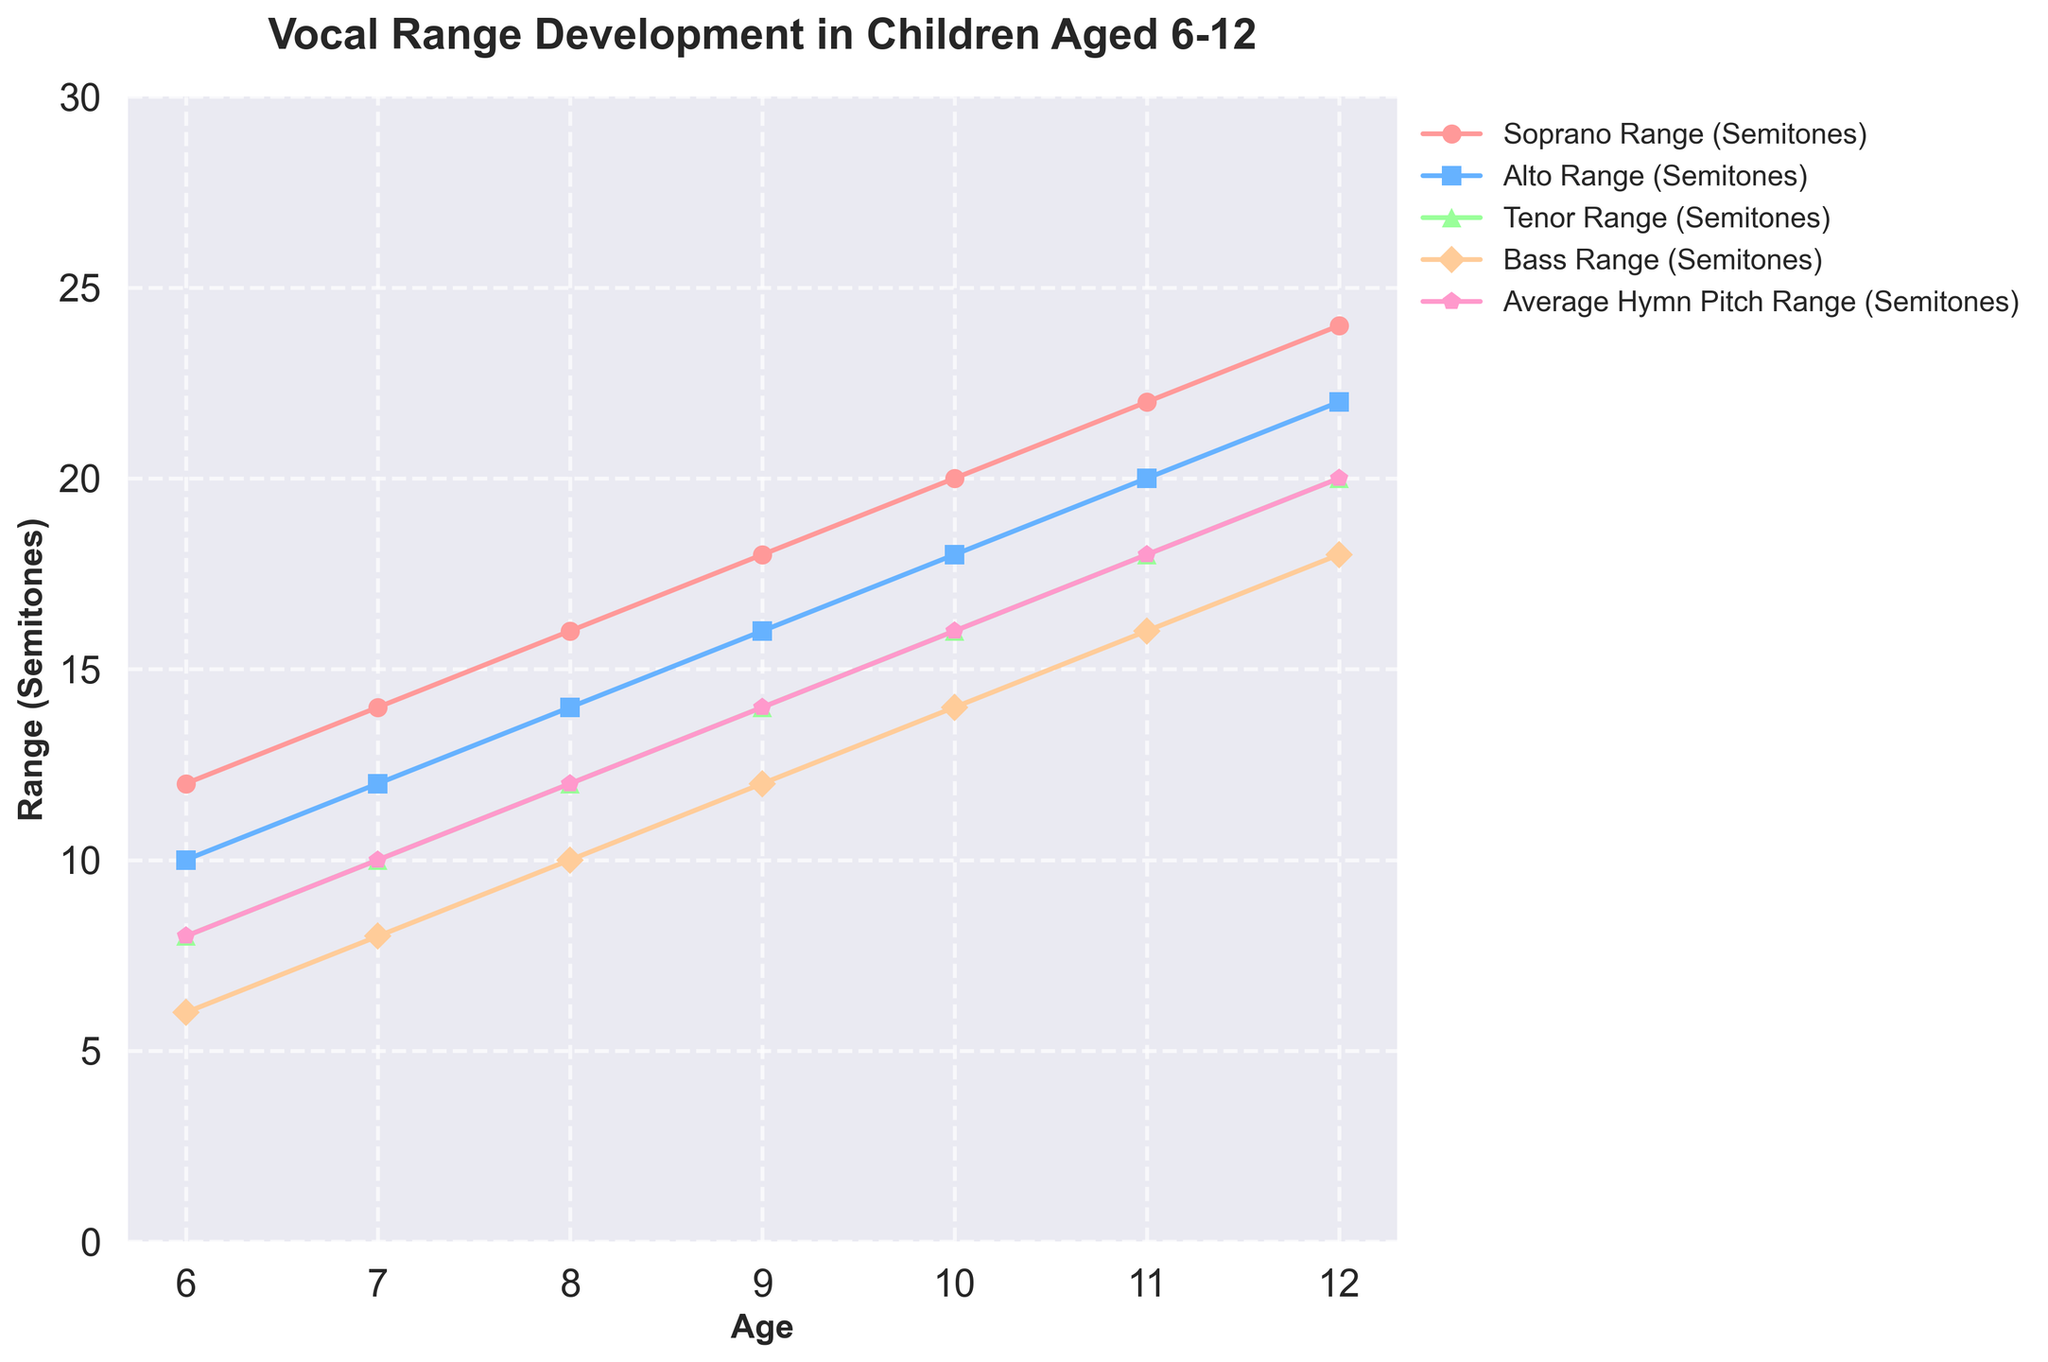Which vocal range shows the greatest increase from age 6 to age 12? To determine the greatest increase, subtract the starting value (at age 6) from the ending value (at age 12) for each vocal range. For Soprano: 24 - 12 = 12 semitones, for Alto: 22 - 10 = 12 semitones, for Tenor: 20 - 8 = 12 semitones, for Bass: 18 - 6 = 12 semitones. All increases are equal.
Answer: All ranges increase by 12 semitones At what age does the Alto range reach 20 semitones? Identify the age at which the Alto range value is 20 on the chart. It is recorded at age 11.
Answer: Age 11 By how many semitones does the Tenor range exceed the Bass range at age 9? Subtract the Bass range from the Tenor range at age 9. The Tenor range is 14, and the Bass range is 12. The difference is 14 - 12 = 2 semitones.
Answer: 2 semitones What age does the Soprano range first exceed 20 semitones? Locate the age where the Soprano range crosses 20 semitones on the plot. The Soprano range exceeds 20 semitones at age 10.
Answer: Age 10 Compare the slope of the Tenor range between ages 7 and 9 to the slope between ages 10 and 12. Calculate the slope (rate of change) in both intervals. For ages 7 to 9, Tenor increases from 10 to 14: slope = (14 - 10) / (9 - 7) = 4 / 2 = 2 semitones per year. For ages 10 to 12, Tenor increases from 16 to 20: slope = (20 - 16) / (12 - 10) = 4 / 2 = 2 semitones per year. Both slopes are the same.
Answer: Slopes are equal At what age do all vocal ranges intersect with the average hymn pitch range? Check at what age all the vocal ranges (Soprano, Alto, Tenor, Bass) equal the average hymn pitch range. At every age, some ranges are higher and others lower than average hymn pitch range. They do not intersect at a single age.
Answer: They do not intersect Between which ages does the Bass range increase by the same number of semitones each year? Find the range where the difference in semitones between successive ages for the Bass range remains constant. From age 6 to 12, the Bass range increases consistently by 2 semitones every year: (8 - 6) / (7 - 6) = 2 semitones/year and continues similarly.
Answer: Age 6 to 12 